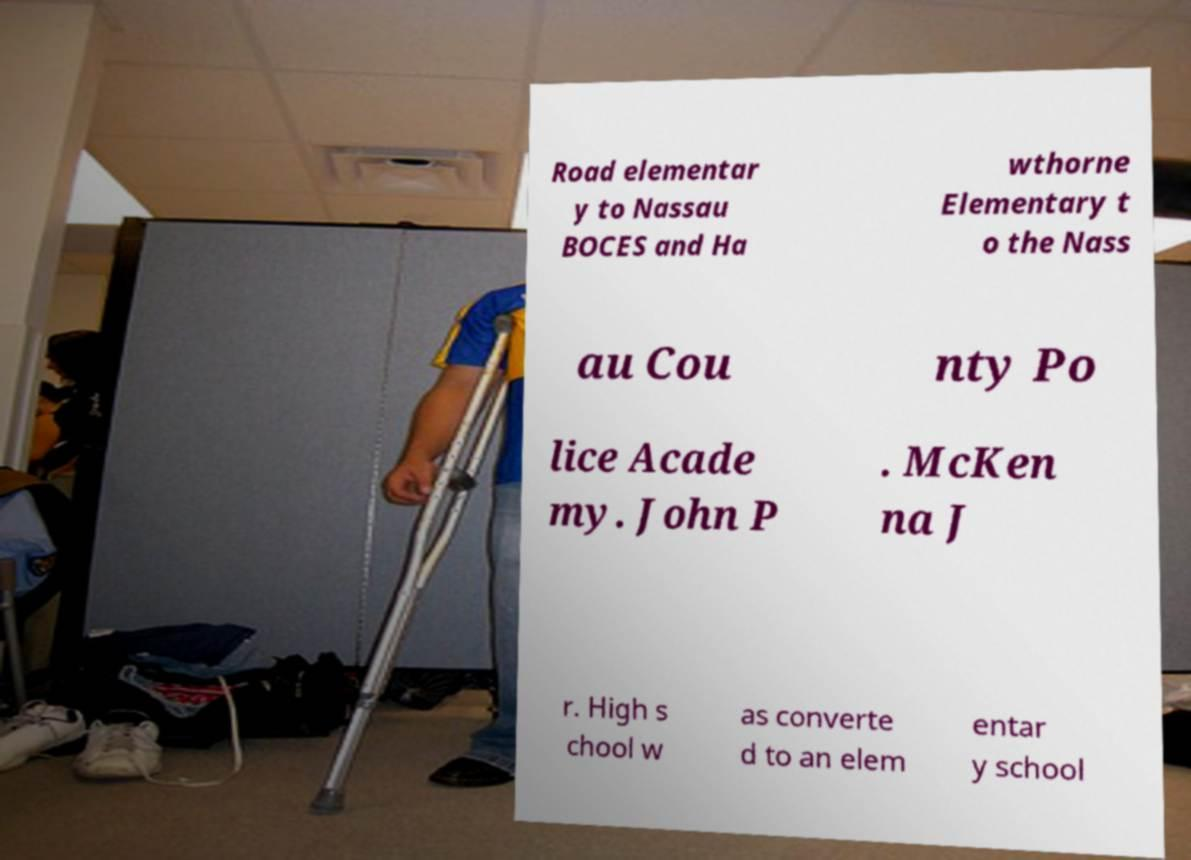Could you extract and type out the text from this image? Road elementar y to Nassau BOCES and Ha wthorne Elementary t o the Nass au Cou nty Po lice Acade my. John P . McKen na J r. High s chool w as converte d to an elem entar y school 